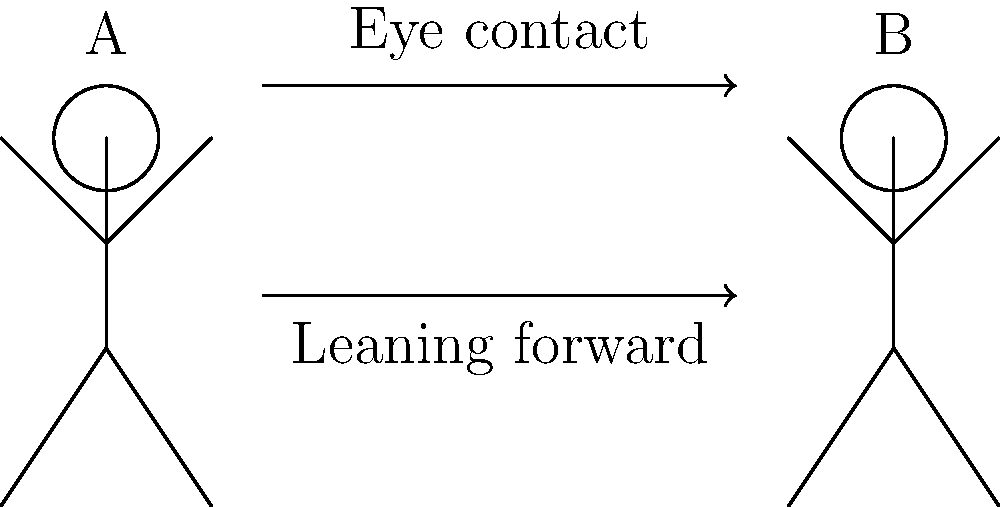In the diagram above, two individuals (A and B) are engaged in a social interaction. Based on the body language cues depicted, what can a traditional psychologist infer about the nature of their interaction, and how might this interpretation differ from a machine-based analysis? To answer this question, a traditional psychologist would consider the following steps:

1. Observe the body language cues:
   a. Eye contact: There is an arrow indicating eye contact between A and B.
   b. Leaning forward: Both figures are shown leaning slightly towards each other.

2. Interpret the meaning of these cues:
   a. Eye contact often indicates engagement, attention, and interest in the conversation.
   b. Leaning forward typically suggests involvement, attentiveness, and a desire to connect.

3. Consider the context:
   The figures are in close proximity, facing each other, which suggests a direct, personal interaction.

4. Draw on psychological theories:
   Theories of nonverbal communication suggest that these cues are generally associated with positive, engaged interactions.

5. Apply clinical experience:
   A traditional psychologist would rely on years of observing human interactions to interpret these cues.

6. Consider individual and cultural differences:
   The psychologist would be aware that the meaning of these cues can vary between individuals and cultures.

7. Contrast with machine-based analysis:
   A traditional psychologist would argue that machines lack the nuanced understanding of human behavior, emotions, and the complex interplay of factors that influence social interactions. They might contend that machines cannot accurately capture the subtleties of human communication or account for the myriad contextual factors that a trained psychologist would consider.

8. Emphasize the importance of human intuition:
   The psychologist would likely stress that their interpretation is based on a holistic understanding of human behavior that goes beyond simple pattern recognition.

Based on these considerations, a traditional psychologist would likely infer that the interaction is positive and engaging, with both participants showing interest and involvement in the conversation.
Answer: Positive, engaged interaction; human interpretation considers nuances machines may miss. 